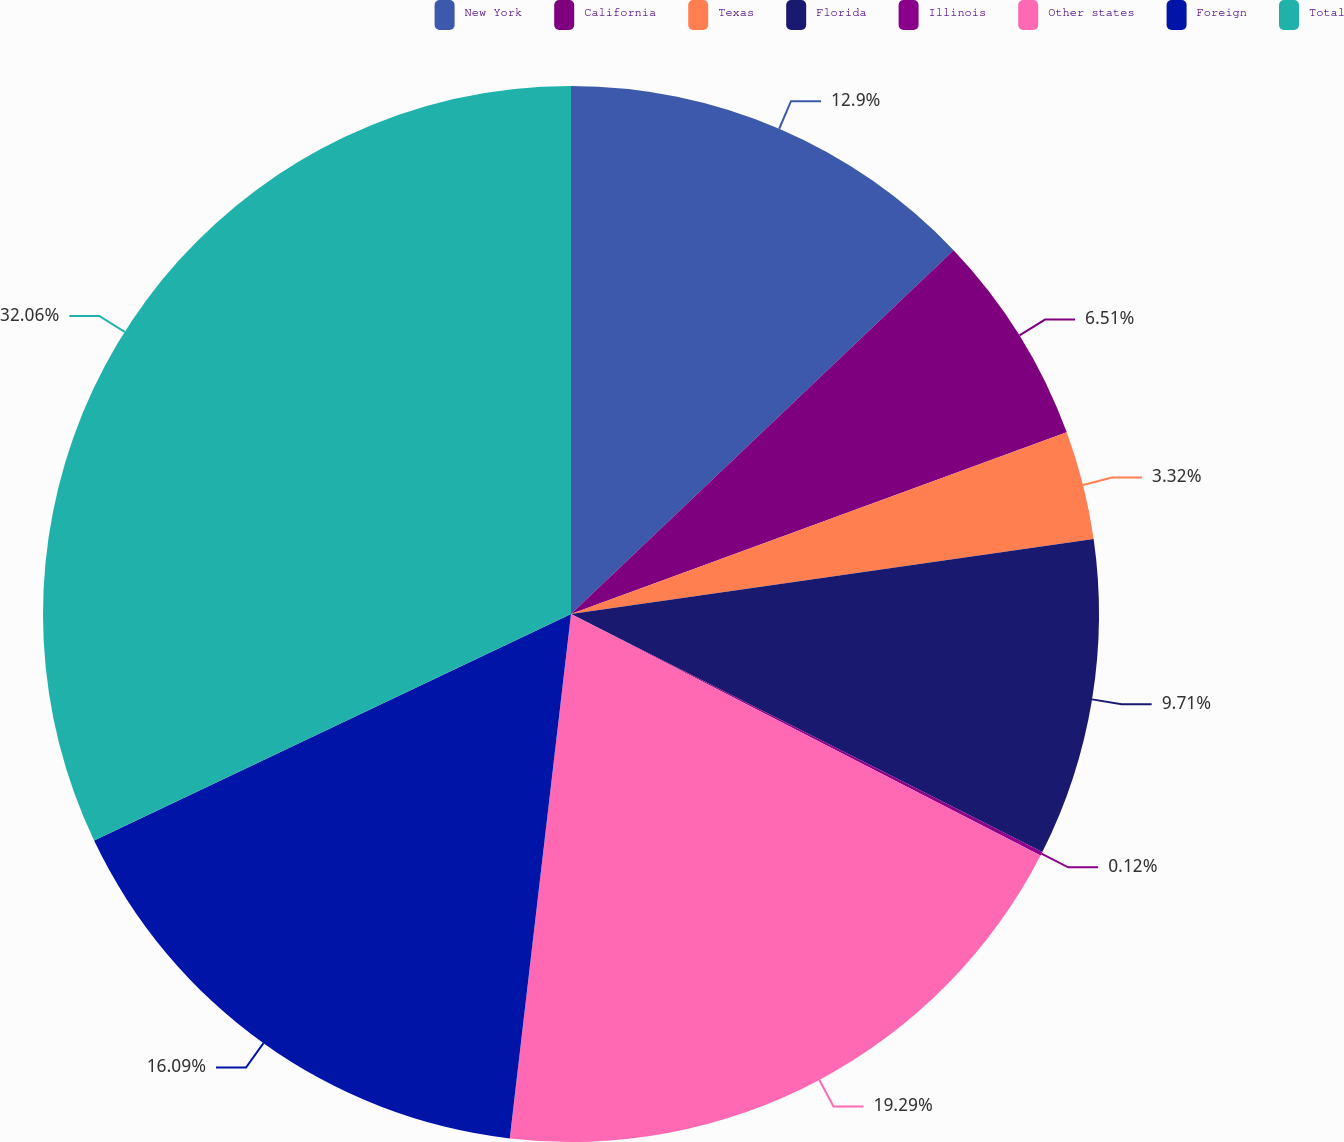Convert chart to OTSL. <chart><loc_0><loc_0><loc_500><loc_500><pie_chart><fcel>New York<fcel>California<fcel>Texas<fcel>Florida<fcel>Illinois<fcel>Other states<fcel>Foreign<fcel>Total<nl><fcel>12.9%<fcel>6.51%<fcel>3.32%<fcel>9.71%<fcel>0.12%<fcel>19.29%<fcel>16.09%<fcel>32.06%<nl></chart> 